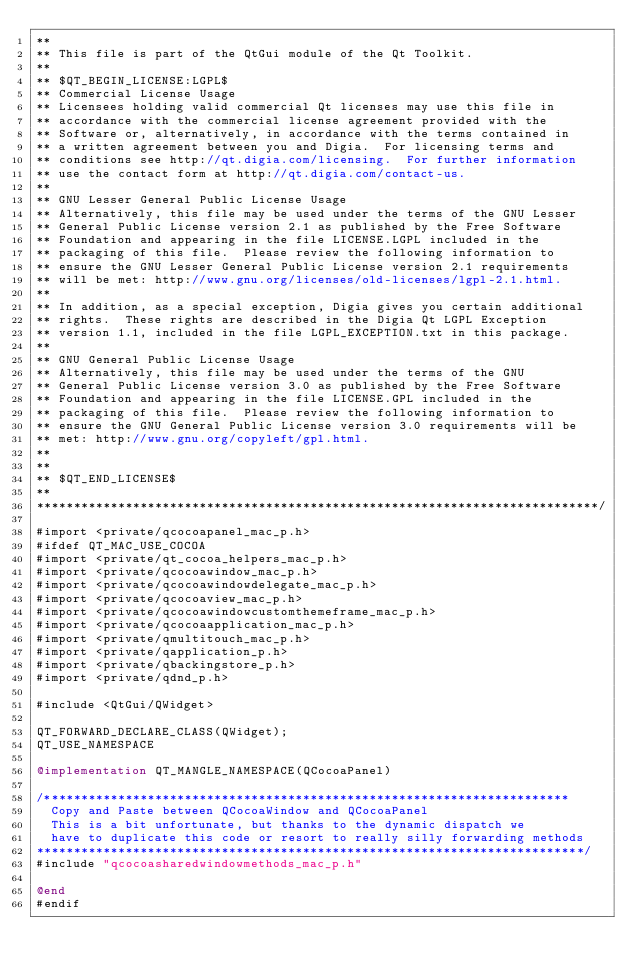Convert code to text. <code><loc_0><loc_0><loc_500><loc_500><_ObjectiveC_>**
** This file is part of the QtGui module of the Qt Toolkit.
**
** $QT_BEGIN_LICENSE:LGPL$
** Commercial License Usage
** Licensees holding valid commercial Qt licenses may use this file in
** accordance with the commercial license agreement provided with the
** Software or, alternatively, in accordance with the terms contained in
** a written agreement between you and Digia.  For licensing terms and
** conditions see http://qt.digia.com/licensing.  For further information
** use the contact form at http://qt.digia.com/contact-us.
**
** GNU Lesser General Public License Usage
** Alternatively, this file may be used under the terms of the GNU Lesser
** General Public License version 2.1 as published by the Free Software
** Foundation and appearing in the file LICENSE.LGPL included in the
** packaging of this file.  Please review the following information to
** ensure the GNU Lesser General Public License version 2.1 requirements
** will be met: http://www.gnu.org/licenses/old-licenses/lgpl-2.1.html.
**
** In addition, as a special exception, Digia gives you certain additional
** rights.  These rights are described in the Digia Qt LGPL Exception
** version 1.1, included in the file LGPL_EXCEPTION.txt in this package.
**
** GNU General Public License Usage
** Alternatively, this file may be used under the terms of the GNU
** General Public License version 3.0 as published by the Free Software
** Foundation and appearing in the file LICENSE.GPL included in the
** packaging of this file.  Please review the following information to
** ensure the GNU General Public License version 3.0 requirements will be
** met: http://www.gnu.org/copyleft/gpl.html.
**
**
** $QT_END_LICENSE$
**
****************************************************************************/

#import <private/qcocoapanel_mac_p.h>
#ifdef QT_MAC_USE_COCOA
#import <private/qt_cocoa_helpers_mac_p.h>
#import <private/qcocoawindow_mac_p.h>
#import <private/qcocoawindowdelegate_mac_p.h>
#import <private/qcocoaview_mac_p.h>
#import <private/qcocoawindowcustomthemeframe_mac_p.h>
#import <private/qcocoaapplication_mac_p.h>
#import <private/qmultitouch_mac_p.h>
#import <private/qapplication_p.h>
#import <private/qbackingstore_p.h>
#import <private/qdnd_p.h>

#include <QtGui/QWidget>

QT_FORWARD_DECLARE_CLASS(QWidget);
QT_USE_NAMESPACE

@implementation QT_MANGLE_NAMESPACE(QCocoaPanel)

/***********************************************************************
  Copy and Paste between QCocoaWindow and QCocoaPanel
  This is a bit unfortunate, but thanks to the dynamic dispatch we
  have to duplicate this code or resort to really silly forwarding methods
**************************************************************************/
#include "qcocoasharedwindowmethods_mac_p.h"

@end
#endif
</code> 